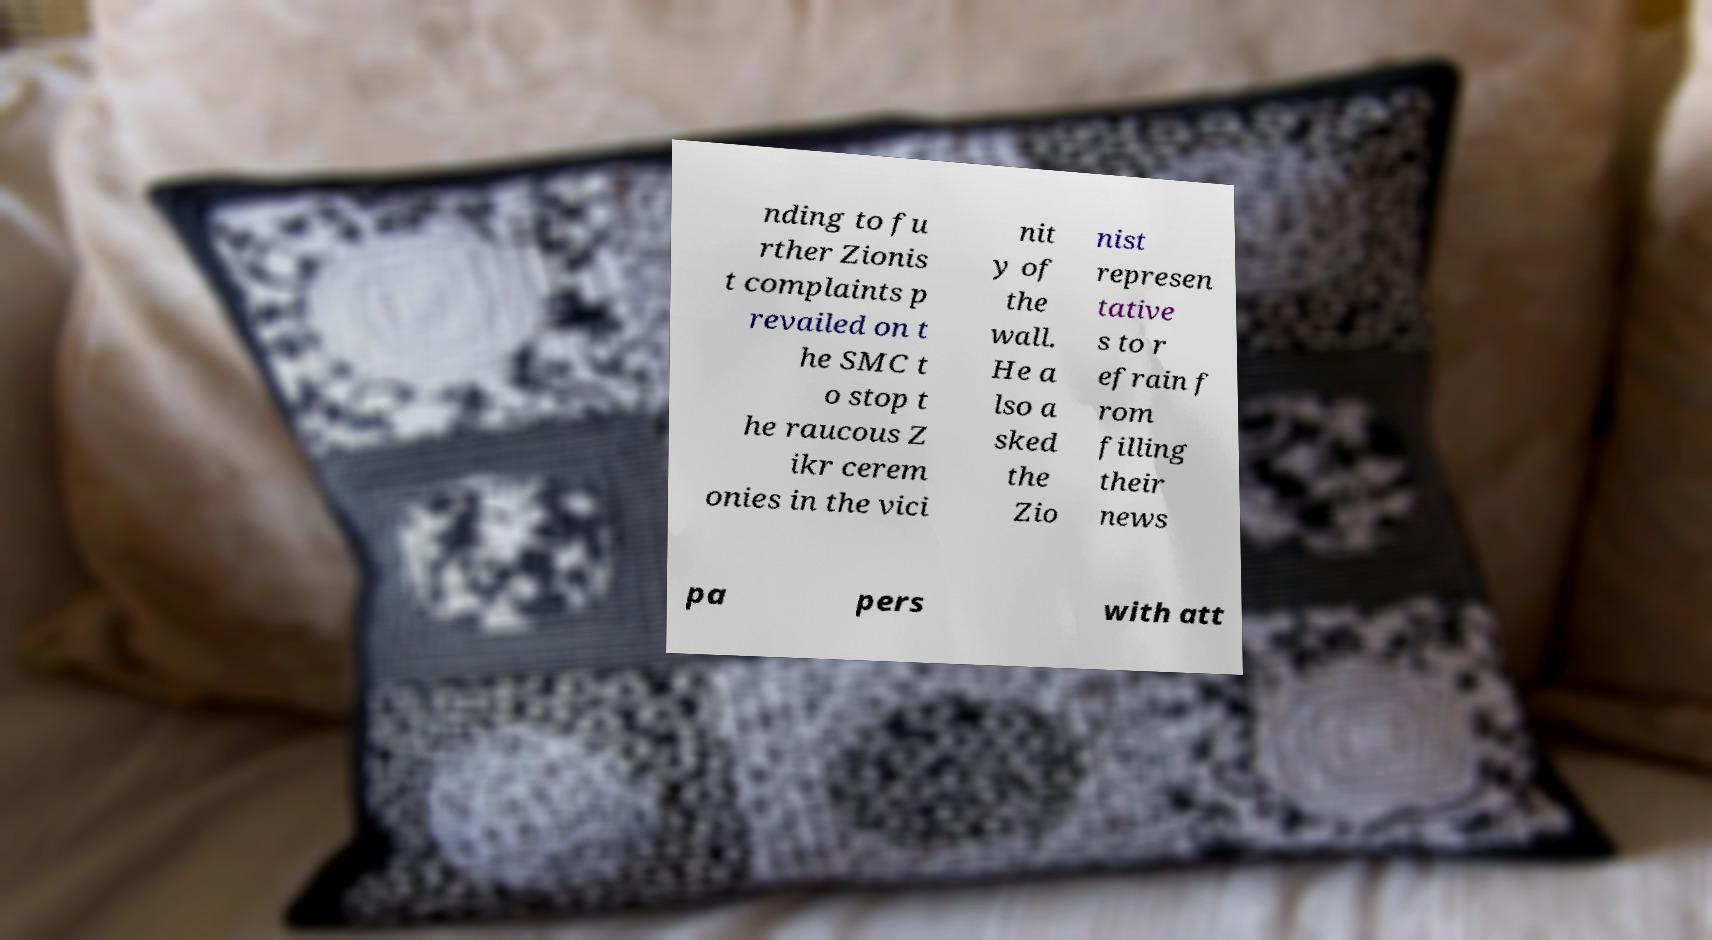For documentation purposes, I need the text within this image transcribed. Could you provide that? nding to fu rther Zionis t complaints p revailed on t he SMC t o stop t he raucous Z ikr cerem onies in the vici nit y of the wall. He a lso a sked the Zio nist represen tative s to r efrain f rom filling their news pa pers with att 